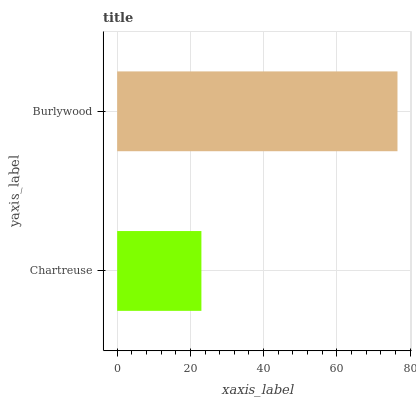Is Chartreuse the minimum?
Answer yes or no. Yes. Is Burlywood the maximum?
Answer yes or no. Yes. Is Burlywood the minimum?
Answer yes or no. No. Is Burlywood greater than Chartreuse?
Answer yes or no. Yes. Is Chartreuse less than Burlywood?
Answer yes or no. Yes. Is Chartreuse greater than Burlywood?
Answer yes or no. No. Is Burlywood less than Chartreuse?
Answer yes or no. No. Is Burlywood the high median?
Answer yes or no. Yes. Is Chartreuse the low median?
Answer yes or no. Yes. Is Chartreuse the high median?
Answer yes or no. No. Is Burlywood the low median?
Answer yes or no. No. 